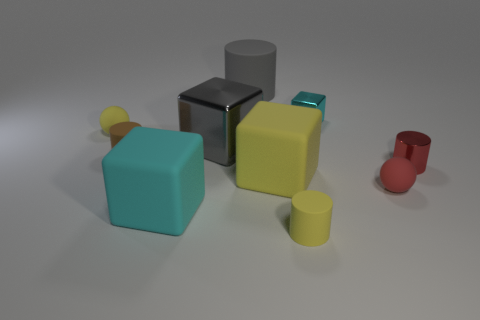There is another matte cube that is the same color as the tiny block; what is its size?
Offer a terse response. Large. What shape is the other object that is the same color as the big shiny object?
Provide a succinct answer. Cylinder. There is a tiny cube; does it have the same color as the matte cylinder that is left of the big cyan matte object?
Provide a succinct answer. No. What number of other things are made of the same material as the small red sphere?
Offer a terse response. 6. Are there more tiny yellow matte spheres than small green metal cylinders?
Your answer should be very brief. Yes. There is a tiny sphere on the left side of the brown cylinder; does it have the same color as the big cylinder?
Keep it short and to the point. No. The small block is what color?
Make the answer very short. Cyan. There is a cylinder that is to the right of the tiny block; are there any big gray shiny cubes to the right of it?
Offer a very short reply. No. There is a large object that is in front of the red object on the left side of the small metal cylinder; what is its shape?
Offer a terse response. Cube. Are there fewer yellow balls than tiny rubber balls?
Offer a terse response. Yes. 